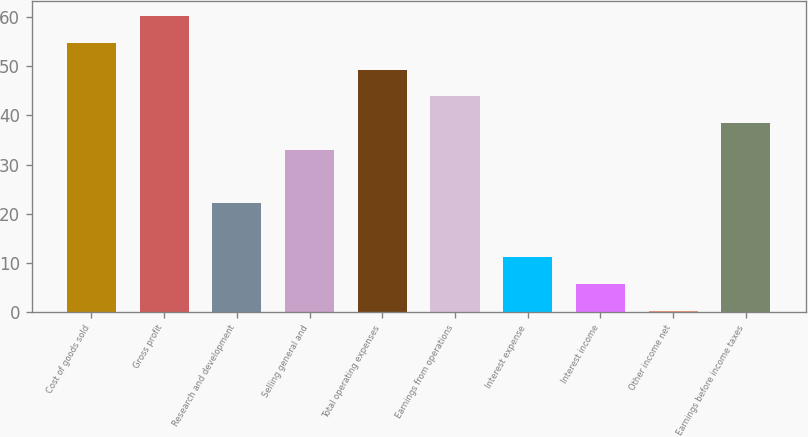Convert chart to OTSL. <chart><loc_0><loc_0><loc_500><loc_500><bar_chart><fcel>Cost of goods sold<fcel>Gross profit<fcel>Research and development<fcel>Selling general and<fcel>Total operating expenses<fcel>Earnings from operations<fcel>Interest expense<fcel>Interest income<fcel>Other income net<fcel>Earnings before income taxes<nl><fcel>54.8<fcel>60.25<fcel>22.1<fcel>33<fcel>49.35<fcel>43.9<fcel>11.2<fcel>5.75<fcel>0.3<fcel>38.45<nl></chart> 